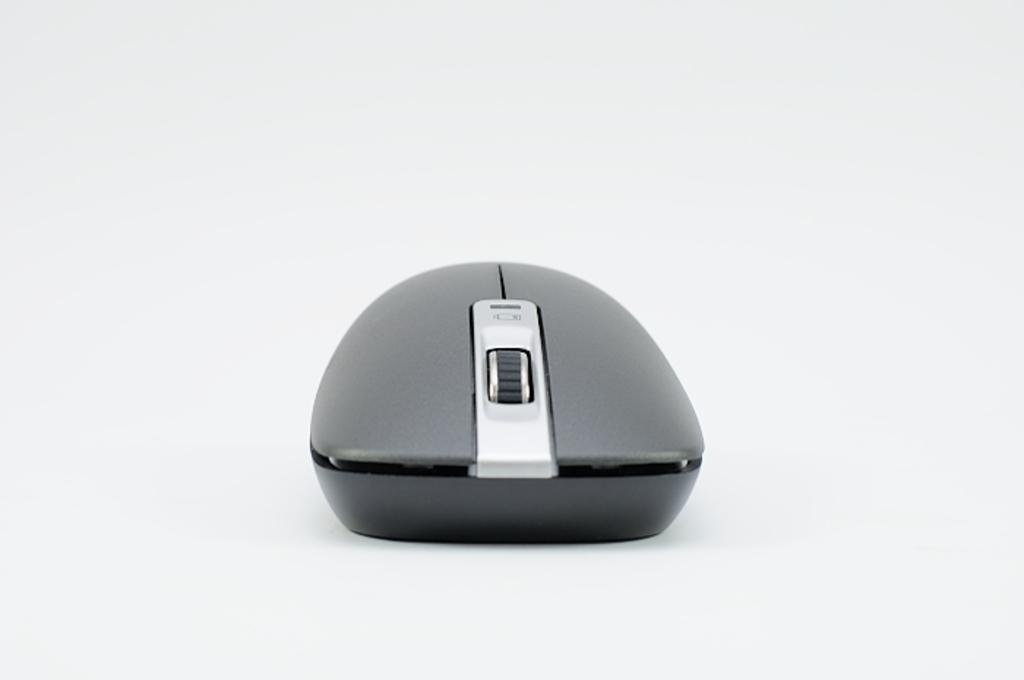What type of device is in the image? There is a wireless mouse in the image. What feature does the wireless mouse have for scrolling? The wireless mouse has a scroll button. How many buttons are present on the wireless mouse? The wireless mouse has left and right buttons. What type of bread is being used as a base for the wireless mouse in the image? There is no bread present in the image; the wireless mouse is not resting on any type of bread. 